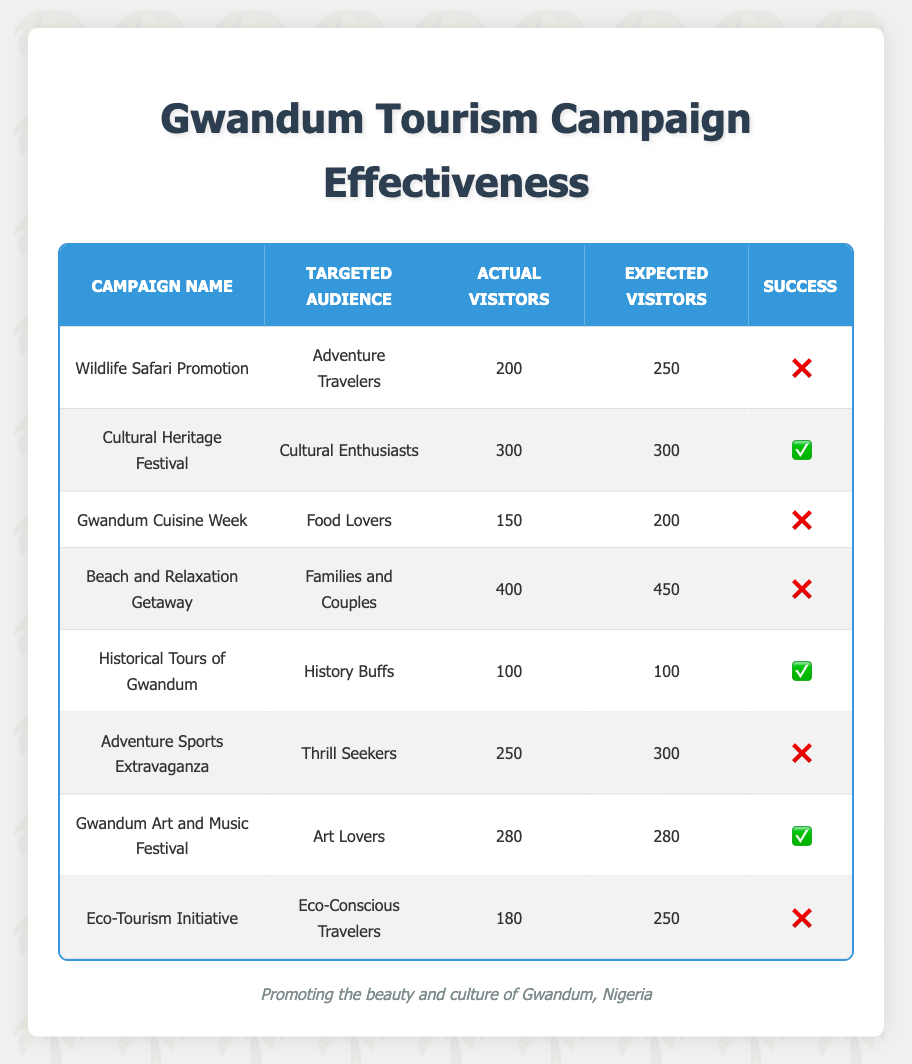What is the actual number of visitors for the Cultural Heritage Festival? The table shows that the actual number of visitors for the Cultural Heritage Festival is listed as 300.
Answer: 300 Which campaign had the most actual visitors? By looking through the actual visitor counts, the Beach and Relaxation Getaway had the most visitors at 400.
Answer: 400 How many campaigns were successful? There are three campaigns that indicate success marked with a checkmark, which are the Cultural Heritage Festival, Historical Tours of Gwandum, and Gwandum Art and Music Festival.
Answer: 3 What is the difference between the expected and actual visitors for the Wildlife Safari Promotion? The expected visitors for the Wildlife Safari Promotion is 250, and the actual visitors are 200, so the difference is 250 - 200 = 50.
Answer: 50 Is the Gwandum Cuisine Week campaign successful? The table shows that the Gwandum Cuisine Week campaign is marked with a cross, indicating it was not successful.
Answer: No What campaign had the least number of actual visitors? Upon reviewing the actual visitor numbers, the Historical Tours of Gwandum had the least actual visitors with a count of 100.
Answer: 100 What percentage of campaigns were unsuccessful? There are a total of 8 campaigns, and 5 of them were unsuccessful. The percentage is (5/8)*100 = 62.5%.
Answer: 62.5% Which targeted audience had a campaign that was successful? The campaigns targeting Cultural Enthusiasts, History Buffs, and Art Lovers were successful according to the table.
Answer: Cultural Enthusiasts, History Buffs, Art Lovers What is the average expected visitors across all campaigns? The total expected visitors across all campaigns is 250 + 300 + 200 + 450 + 100 + 300 + 280 + 250 = 1930. The average is 1930/8 = 241.25.
Answer: 241.25 